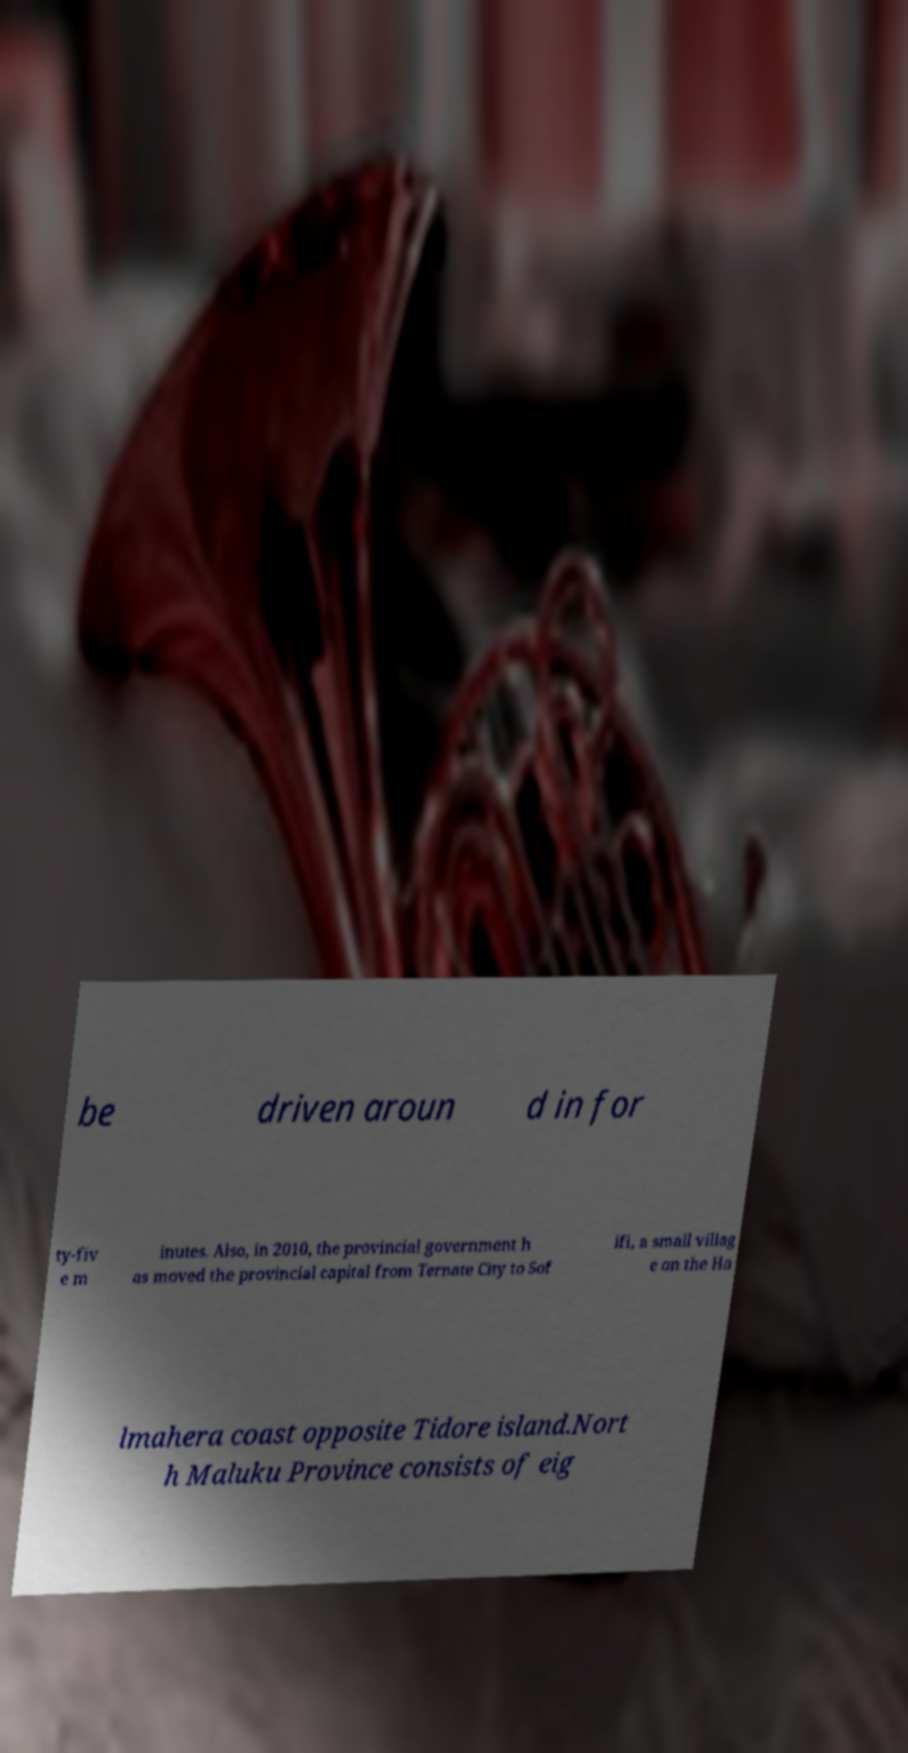I need the written content from this picture converted into text. Can you do that? be driven aroun d in for ty-fiv e m inutes. Also, in 2010, the provincial government h as moved the provincial capital from Ternate City to Sof ifi, a small villag e on the Ha lmahera coast opposite Tidore island.Nort h Maluku Province consists of eig 